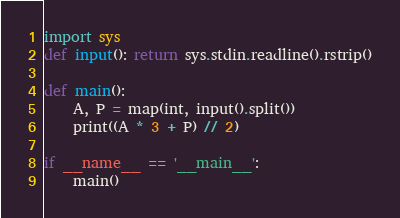Convert code to text. <code><loc_0><loc_0><loc_500><loc_500><_Python_>import sys
def input(): return sys.stdin.readline().rstrip()

def main():
    A, P = map(int, input().split())
    print((A * 3 + P) // 2)    

if __name__ == '__main__':
    main()
</code> 